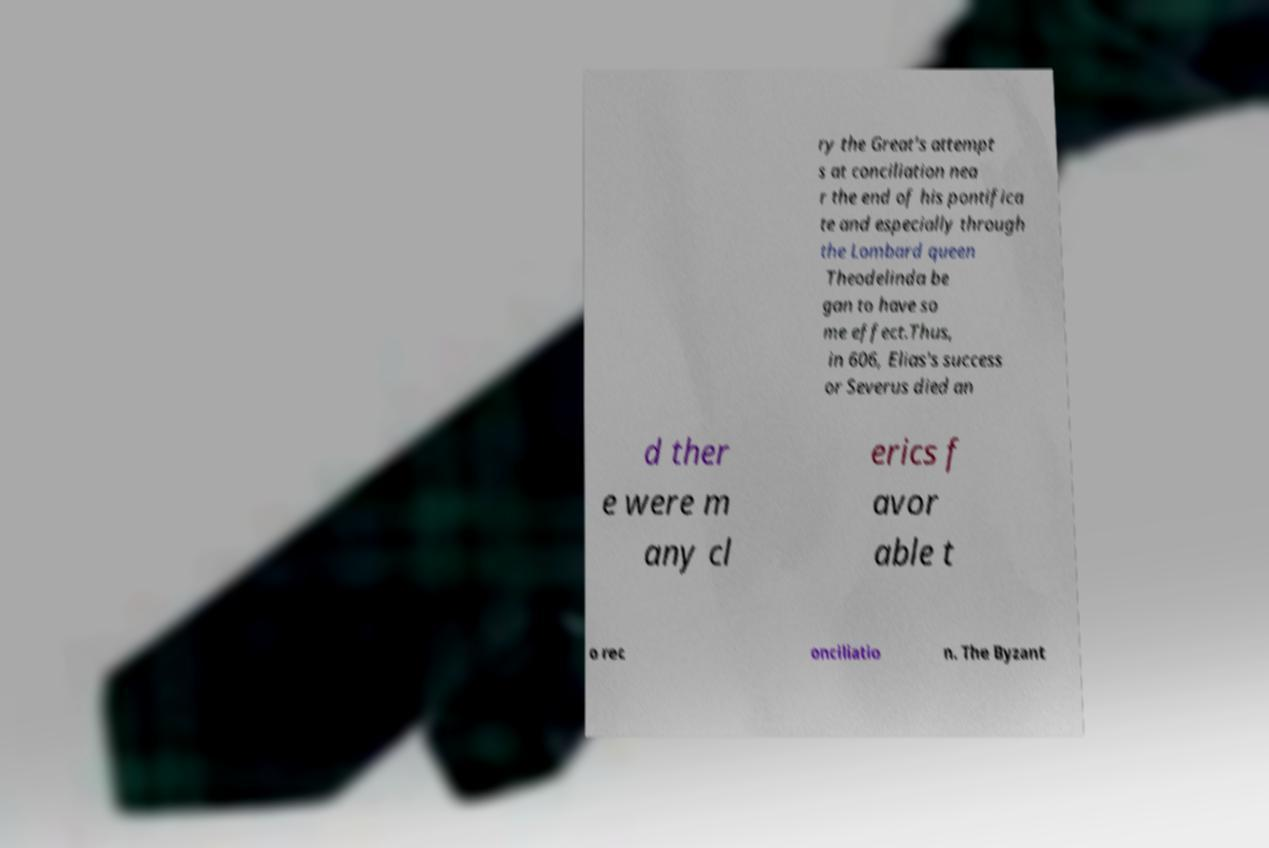Please read and relay the text visible in this image. What does it say? ry the Great's attempt s at conciliation nea r the end of his pontifica te and especially through the Lombard queen Theodelinda be gan to have so me effect.Thus, in 606, Elias's success or Severus died an d ther e were m any cl erics f avor able t o rec onciliatio n. The Byzant 